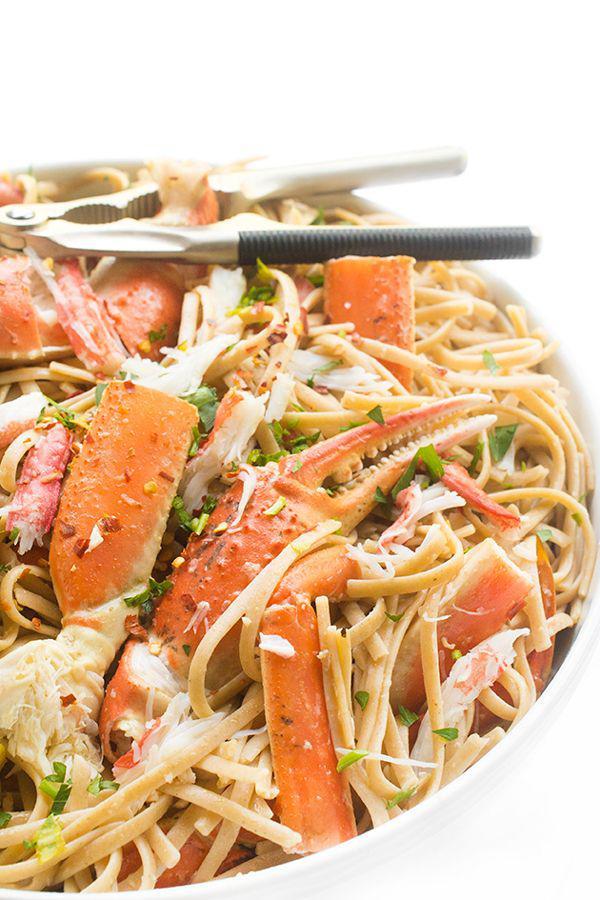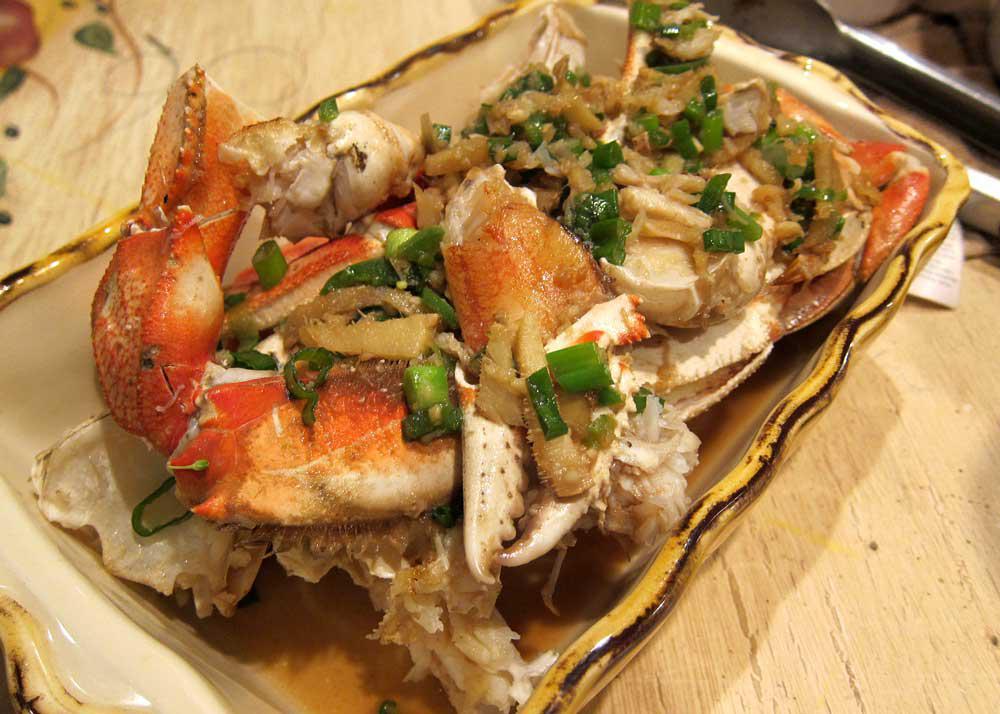The first image is the image on the left, the second image is the image on the right. For the images shown, is this caption "At least one crab dish is served with a lemon next to the crab on the plate." true? Answer yes or no. No. The first image is the image on the left, the second image is the image on the right. Evaluate the accuracy of this statement regarding the images: "In at least one image there is a cooked fullcrab facing left and forward.". Is it true? Answer yes or no. No. 